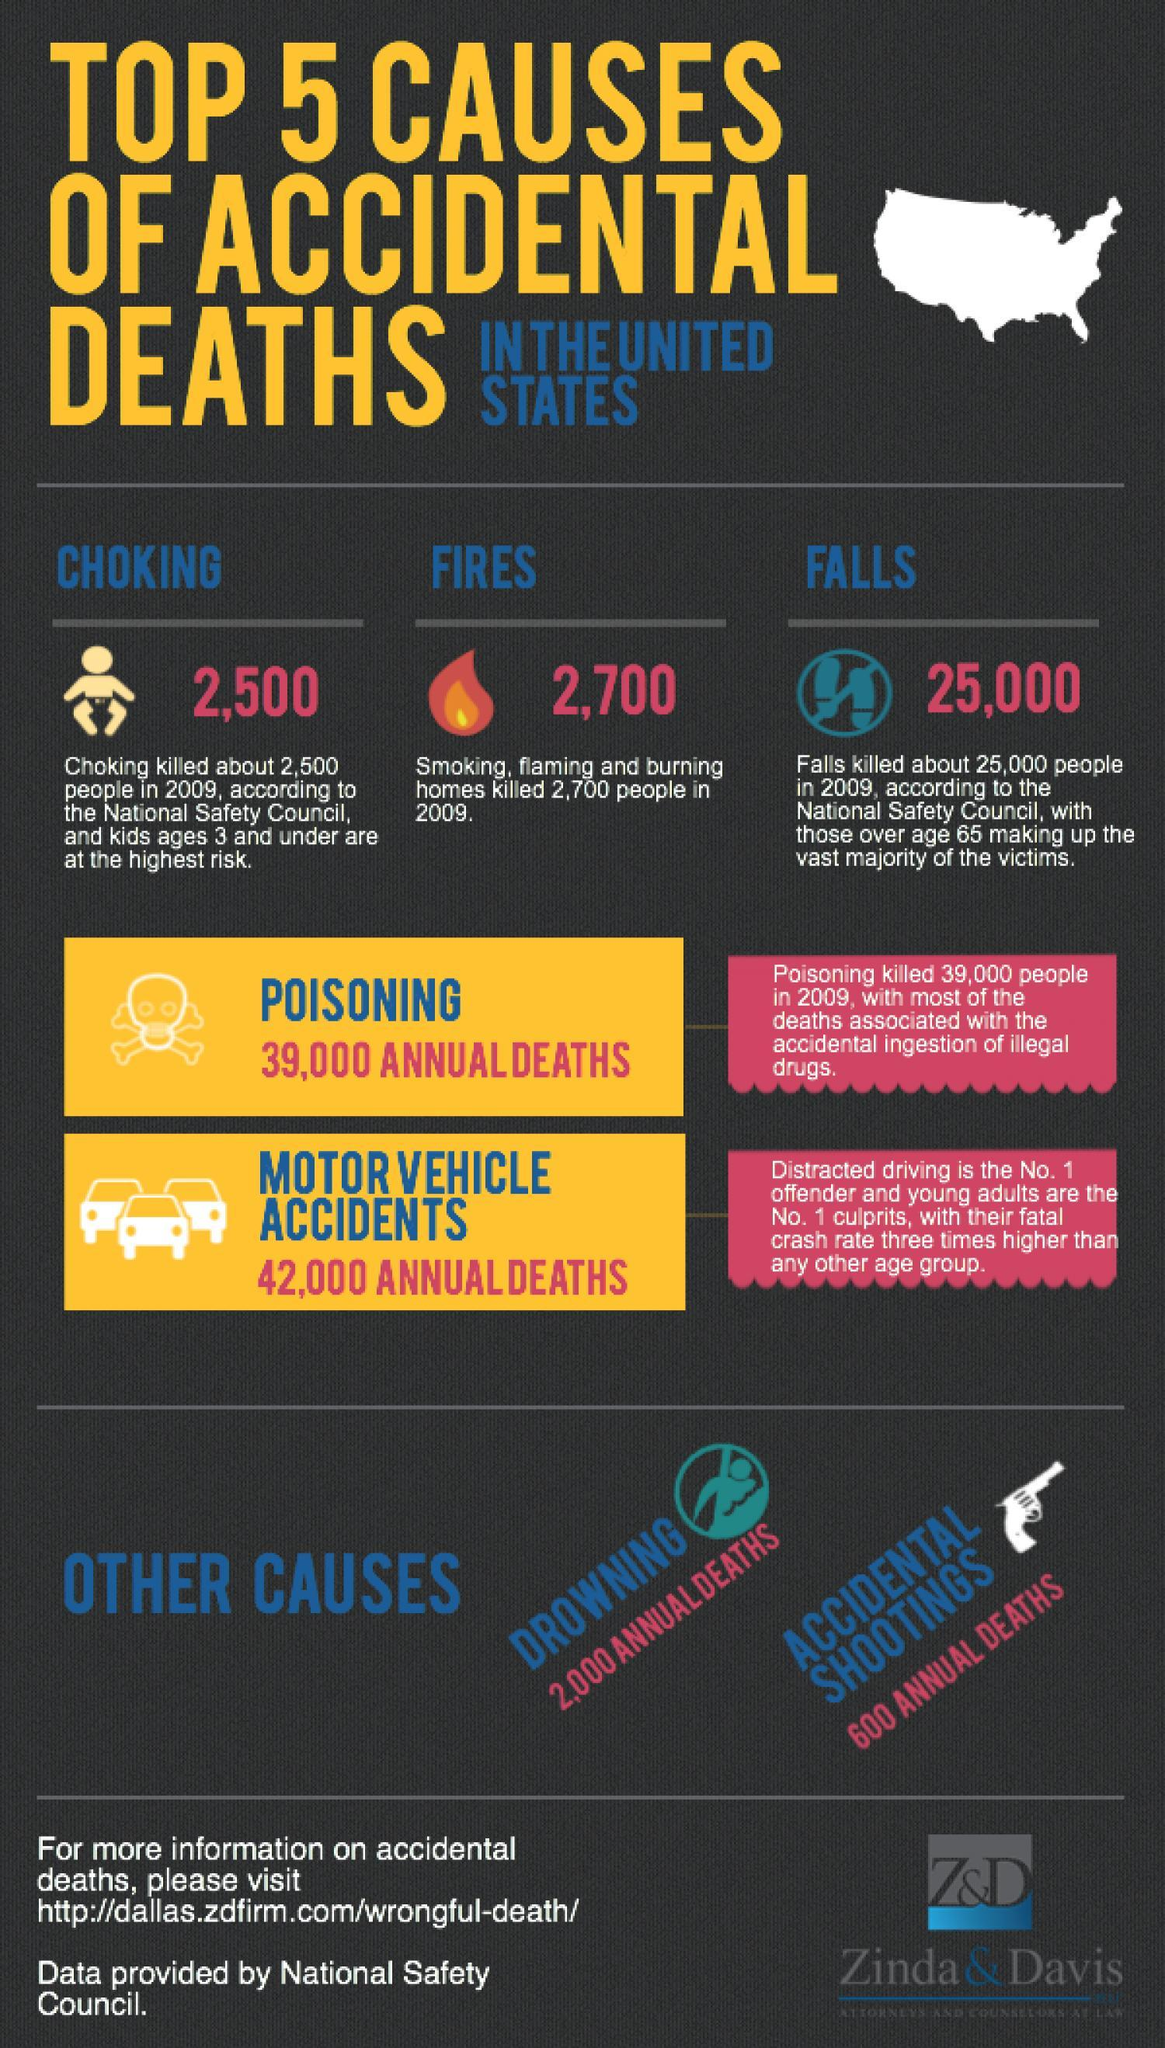What is the average number of annual deaths from drowning?
Answer the question with a short phrase. 2,000 Which is the second major reason for acccidental deaths? poisoning Among the 5 reasons listed here, which one is the major reason for accidental deaths? motor vehicle accidents In 2009, in Us, more people died from drowning, falls or accidental shootings? falls 